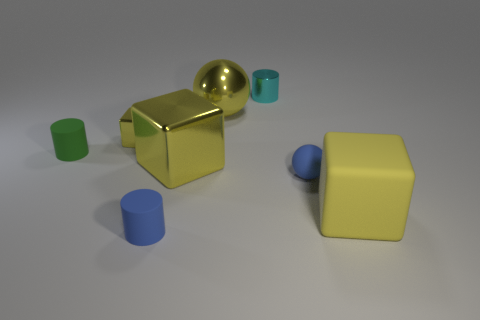The yellow metal thing behind the block behind the green matte cylinder is what shape?
Ensure brevity in your answer.  Sphere. Is the number of tiny green objects that are behind the cyan metallic cylinder the same as the number of large gray metallic things?
Your response must be concise. Yes. There is a rubber ball; is its color the same as the matte cylinder in front of the large yellow metallic cube?
Your answer should be very brief. Yes. There is a block that is behind the large yellow rubber cube and on the right side of the small yellow block; what is its color?
Offer a terse response. Yellow. How many big metal blocks are in front of the small rubber ball that is in front of the large metal cube?
Make the answer very short. 0. Is there a large purple object that has the same shape as the cyan metallic object?
Offer a very short reply. No. There is a tiny blue thing that is left of the small cyan object; does it have the same shape as the big yellow metallic object in front of the tiny yellow block?
Your answer should be compact. No. How many objects are yellow cylinders or yellow metal spheres?
Your answer should be very brief. 1. The matte thing that is the same shape as the tiny yellow metallic thing is what size?
Provide a succinct answer. Large. Is the number of small green rubber cylinders in front of the tiny blue cylinder greater than the number of green matte cylinders?
Your response must be concise. No. 